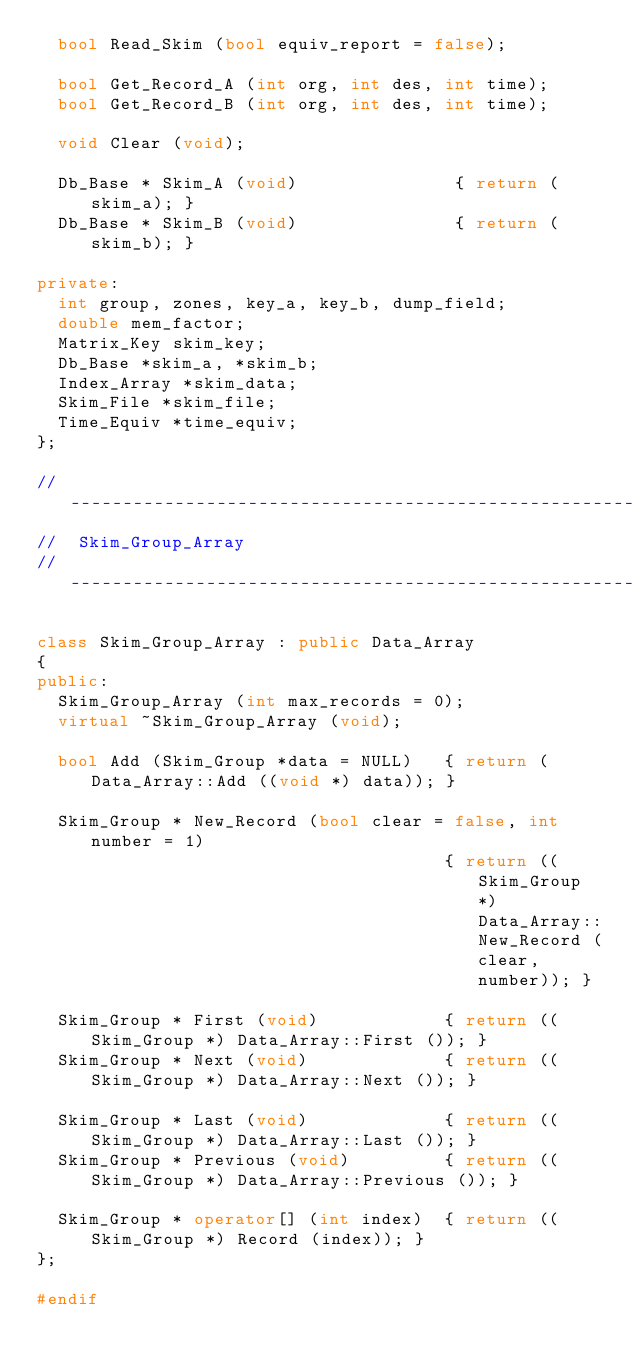Convert code to text. <code><loc_0><loc_0><loc_500><loc_500><_C++_>	bool Read_Skim (bool equiv_report = false);

	bool Get_Record_A (int org, int des, int time);
	bool Get_Record_B (int org, int des, int time);

	void Clear (void);

	Db_Base * Skim_A (void)               { return (skim_a); }
	Db_Base * Skim_B (void)               { return (skim_b); }

private:
	int group, zones, key_a, key_b, dump_field;
	double mem_factor;
	Matrix_Key skim_key;
	Db_Base *skim_a, *skim_b;
	Index_Array *skim_data;
	Skim_File *skim_file;
	Time_Equiv *time_equiv;
};

//---------------------------------------------------------
//	Skim_Group_Array
//---------------------------------------------------------

class Skim_Group_Array : public Data_Array
{
public:
	Skim_Group_Array (int max_records = 0);
	virtual ~Skim_Group_Array (void);

	bool Add (Skim_Group *data = NULL)   { return (Data_Array::Add ((void *) data)); }

	Skim_Group * New_Record (bool clear = false, int number = 1)
	                                     { return ((Skim_Group *) Data_Array::New_Record (clear, number)); }

	Skim_Group * First (void)            { return ((Skim_Group *) Data_Array::First ()); }
	Skim_Group * Next (void)             { return ((Skim_Group *) Data_Array::Next ()); }

	Skim_Group * Last (void)             { return ((Skim_Group *) Data_Array::Last ()); }
	Skim_Group * Previous (void)         { return ((Skim_Group *) Data_Array::Previous ()); }

	Skim_Group * operator[] (int index)  { return ((Skim_Group *) Record (index)); }
};

#endif

</code> 